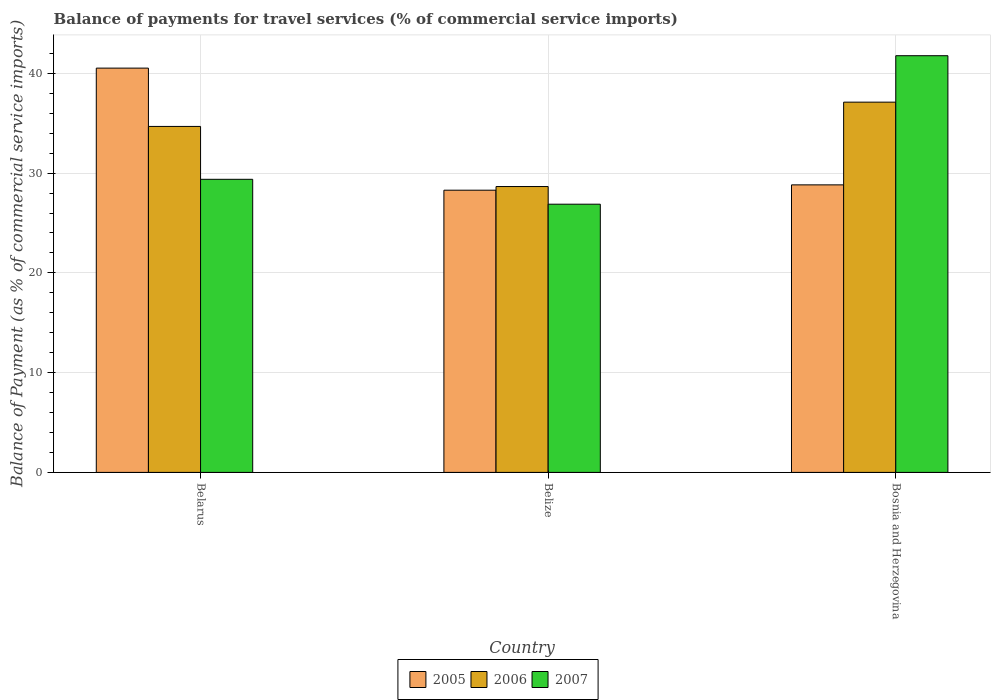How many different coloured bars are there?
Your answer should be compact. 3. Are the number of bars per tick equal to the number of legend labels?
Provide a short and direct response. Yes. Are the number of bars on each tick of the X-axis equal?
Your response must be concise. Yes. What is the label of the 3rd group of bars from the left?
Offer a terse response. Bosnia and Herzegovina. In how many cases, is the number of bars for a given country not equal to the number of legend labels?
Your answer should be very brief. 0. What is the balance of payments for travel services in 2005 in Bosnia and Herzegovina?
Your response must be concise. 28.82. Across all countries, what is the maximum balance of payments for travel services in 2007?
Make the answer very short. 41.77. Across all countries, what is the minimum balance of payments for travel services in 2007?
Keep it short and to the point. 26.89. In which country was the balance of payments for travel services in 2005 maximum?
Offer a very short reply. Belarus. In which country was the balance of payments for travel services in 2007 minimum?
Your answer should be very brief. Belize. What is the total balance of payments for travel services in 2005 in the graph?
Keep it short and to the point. 97.64. What is the difference between the balance of payments for travel services in 2006 in Belize and that in Bosnia and Herzegovina?
Your answer should be very brief. -8.46. What is the difference between the balance of payments for travel services in 2005 in Bosnia and Herzegovina and the balance of payments for travel services in 2007 in Belarus?
Offer a terse response. -0.56. What is the average balance of payments for travel services in 2007 per country?
Your answer should be compact. 32.68. What is the difference between the balance of payments for travel services of/in 2006 and balance of payments for travel services of/in 2005 in Belarus?
Your answer should be compact. -5.85. In how many countries, is the balance of payments for travel services in 2005 greater than 26 %?
Keep it short and to the point. 3. What is the ratio of the balance of payments for travel services in 2006 in Belize to that in Bosnia and Herzegovina?
Ensure brevity in your answer.  0.77. What is the difference between the highest and the second highest balance of payments for travel services in 2005?
Ensure brevity in your answer.  11.7. What is the difference between the highest and the lowest balance of payments for travel services in 2007?
Your answer should be very brief. 14.88. Is the sum of the balance of payments for travel services in 2006 in Belarus and Bosnia and Herzegovina greater than the maximum balance of payments for travel services in 2007 across all countries?
Your answer should be compact. Yes. What does the 3rd bar from the right in Bosnia and Herzegovina represents?
Keep it short and to the point. 2005. Is it the case that in every country, the sum of the balance of payments for travel services in 2006 and balance of payments for travel services in 2007 is greater than the balance of payments for travel services in 2005?
Your answer should be compact. Yes. How many bars are there?
Your answer should be compact. 9. Are all the bars in the graph horizontal?
Your response must be concise. No. What is the difference between two consecutive major ticks on the Y-axis?
Provide a succinct answer. 10. Are the values on the major ticks of Y-axis written in scientific E-notation?
Your answer should be very brief. No. Where does the legend appear in the graph?
Offer a terse response. Bottom center. How many legend labels are there?
Offer a terse response. 3. How are the legend labels stacked?
Your answer should be very brief. Horizontal. What is the title of the graph?
Provide a succinct answer. Balance of payments for travel services (% of commercial service imports). What is the label or title of the Y-axis?
Make the answer very short. Balance of Payment (as % of commercial service imports). What is the Balance of Payment (as % of commercial service imports) in 2005 in Belarus?
Keep it short and to the point. 40.53. What is the Balance of Payment (as % of commercial service imports) in 2006 in Belarus?
Your response must be concise. 34.68. What is the Balance of Payment (as % of commercial service imports) of 2007 in Belarus?
Your response must be concise. 29.38. What is the Balance of Payment (as % of commercial service imports) of 2005 in Belize?
Offer a very short reply. 28.29. What is the Balance of Payment (as % of commercial service imports) in 2006 in Belize?
Provide a short and direct response. 28.66. What is the Balance of Payment (as % of commercial service imports) of 2007 in Belize?
Give a very brief answer. 26.89. What is the Balance of Payment (as % of commercial service imports) of 2005 in Bosnia and Herzegovina?
Keep it short and to the point. 28.82. What is the Balance of Payment (as % of commercial service imports) in 2006 in Bosnia and Herzegovina?
Offer a terse response. 37.12. What is the Balance of Payment (as % of commercial service imports) in 2007 in Bosnia and Herzegovina?
Provide a short and direct response. 41.77. Across all countries, what is the maximum Balance of Payment (as % of commercial service imports) in 2005?
Provide a succinct answer. 40.53. Across all countries, what is the maximum Balance of Payment (as % of commercial service imports) in 2006?
Give a very brief answer. 37.12. Across all countries, what is the maximum Balance of Payment (as % of commercial service imports) in 2007?
Make the answer very short. 41.77. Across all countries, what is the minimum Balance of Payment (as % of commercial service imports) of 2005?
Your answer should be very brief. 28.29. Across all countries, what is the minimum Balance of Payment (as % of commercial service imports) in 2006?
Your answer should be very brief. 28.66. Across all countries, what is the minimum Balance of Payment (as % of commercial service imports) in 2007?
Offer a very short reply. 26.89. What is the total Balance of Payment (as % of commercial service imports) in 2005 in the graph?
Ensure brevity in your answer.  97.64. What is the total Balance of Payment (as % of commercial service imports) in 2006 in the graph?
Keep it short and to the point. 100.45. What is the total Balance of Payment (as % of commercial service imports) in 2007 in the graph?
Offer a terse response. 98.04. What is the difference between the Balance of Payment (as % of commercial service imports) in 2005 in Belarus and that in Belize?
Your response must be concise. 12.24. What is the difference between the Balance of Payment (as % of commercial service imports) of 2006 in Belarus and that in Belize?
Your response must be concise. 6.03. What is the difference between the Balance of Payment (as % of commercial service imports) in 2007 in Belarus and that in Belize?
Ensure brevity in your answer.  2.49. What is the difference between the Balance of Payment (as % of commercial service imports) in 2005 in Belarus and that in Bosnia and Herzegovina?
Your answer should be compact. 11.7. What is the difference between the Balance of Payment (as % of commercial service imports) in 2006 in Belarus and that in Bosnia and Herzegovina?
Your answer should be compact. -2.43. What is the difference between the Balance of Payment (as % of commercial service imports) of 2007 in Belarus and that in Bosnia and Herzegovina?
Offer a very short reply. -12.39. What is the difference between the Balance of Payment (as % of commercial service imports) in 2005 in Belize and that in Bosnia and Herzegovina?
Your answer should be very brief. -0.53. What is the difference between the Balance of Payment (as % of commercial service imports) in 2006 in Belize and that in Bosnia and Herzegovina?
Give a very brief answer. -8.46. What is the difference between the Balance of Payment (as % of commercial service imports) of 2007 in Belize and that in Bosnia and Herzegovina?
Give a very brief answer. -14.88. What is the difference between the Balance of Payment (as % of commercial service imports) of 2005 in Belarus and the Balance of Payment (as % of commercial service imports) of 2006 in Belize?
Offer a terse response. 11.87. What is the difference between the Balance of Payment (as % of commercial service imports) in 2005 in Belarus and the Balance of Payment (as % of commercial service imports) in 2007 in Belize?
Provide a succinct answer. 13.64. What is the difference between the Balance of Payment (as % of commercial service imports) of 2006 in Belarus and the Balance of Payment (as % of commercial service imports) of 2007 in Belize?
Your response must be concise. 7.8. What is the difference between the Balance of Payment (as % of commercial service imports) of 2005 in Belarus and the Balance of Payment (as % of commercial service imports) of 2006 in Bosnia and Herzegovina?
Provide a short and direct response. 3.41. What is the difference between the Balance of Payment (as % of commercial service imports) of 2005 in Belarus and the Balance of Payment (as % of commercial service imports) of 2007 in Bosnia and Herzegovina?
Offer a terse response. -1.24. What is the difference between the Balance of Payment (as % of commercial service imports) in 2006 in Belarus and the Balance of Payment (as % of commercial service imports) in 2007 in Bosnia and Herzegovina?
Provide a succinct answer. -7.09. What is the difference between the Balance of Payment (as % of commercial service imports) in 2005 in Belize and the Balance of Payment (as % of commercial service imports) in 2006 in Bosnia and Herzegovina?
Ensure brevity in your answer.  -8.83. What is the difference between the Balance of Payment (as % of commercial service imports) of 2005 in Belize and the Balance of Payment (as % of commercial service imports) of 2007 in Bosnia and Herzegovina?
Your response must be concise. -13.48. What is the difference between the Balance of Payment (as % of commercial service imports) of 2006 in Belize and the Balance of Payment (as % of commercial service imports) of 2007 in Bosnia and Herzegovina?
Give a very brief answer. -13.12. What is the average Balance of Payment (as % of commercial service imports) of 2005 per country?
Provide a short and direct response. 32.55. What is the average Balance of Payment (as % of commercial service imports) of 2006 per country?
Provide a succinct answer. 33.48. What is the average Balance of Payment (as % of commercial service imports) in 2007 per country?
Your answer should be compact. 32.68. What is the difference between the Balance of Payment (as % of commercial service imports) of 2005 and Balance of Payment (as % of commercial service imports) of 2006 in Belarus?
Your response must be concise. 5.85. What is the difference between the Balance of Payment (as % of commercial service imports) in 2005 and Balance of Payment (as % of commercial service imports) in 2007 in Belarus?
Ensure brevity in your answer.  11.15. What is the difference between the Balance of Payment (as % of commercial service imports) in 2006 and Balance of Payment (as % of commercial service imports) in 2007 in Belarus?
Provide a short and direct response. 5.3. What is the difference between the Balance of Payment (as % of commercial service imports) in 2005 and Balance of Payment (as % of commercial service imports) in 2006 in Belize?
Provide a succinct answer. -0.37. What is the difference between the Balance of Payment (as % of commercial service imports) in 2005 and Balance of Payment (as % of commercial service imports) in 2007 in Belize?
Offer a terse response. 1.4. What is the difference between the Balance of Payment (as % of commercial service imports) of 2006 and Balance of Payment (as % of commercial service imports) of 2007 in Belize?
Offer a terse response. 1.77. What is the difference between the Balance of Payment (as % of commercial service imports) in 2005 and Balance of Payment (as % of commercial service imports) in 2006 in Bosnia and Herzegovina?
Provide a succinct answer. -8.29. What is the difference between the Balance of Payment (as % of commercial service imports) in 2005 and Balance of Payment (as % of commercial service imports) in 2007 in Bosnia and Herzegovina?
Provide a succinct answer. -12.95. What is the difference between the Balance of Payment (as % of commercial service imports) in 2006 and Balance of Payment (as % of commercial service imports) in 2007 in Bosnia and Herzegovina?
Make the answer very short. -4.66. What is the ratio of the Balance of Payment (as % of commercial service imports) of 2005 in Belarus to that in Belize?
Offer a terse response. 1.43. What is the ratio of the Balance of Payment (as % of commercial service imports) in 2006 in Belarus to that in Belize?
Offer a terse response. 1.21. What is the ratio of the Balance of Payment (as % of commercial service imports) in 2007 in Belarus to that in Belize?
Your answer should be compact. 1.09. What is the ratio of the Balance of Payment (as % of commercial service imports) in 2005 in Belarus to that in Bosnia and Herzegovina?
Your answer should be compact. 1.41. What is the ratio of the Balance of Payment (as % of commercial service imports) of 2006 in Belarus to that in Bosnia and Herzegovina?
Keep it short and to the point. 0.93. What is the ratio of the Balance of Payment (as % of commercial service imports) in 2007 in Belarus to that in Bosnia and Herzegovina?
Make the answer very short. 0.7. What is the ratio of the Balance of Payment (as % of commercial service imports) in 2005 in Belize to that in Bosnia and Herzegovina?
Keep it short and to the point. 0.98. What is the ratio of the Balance of Payment (as % of commercial service imports) of 2006 in Belize to that in Bosnia and Herzegovina?
Provide a succinct answer. 0.77. What is the ratio of the Balance of Payment (as % of commercial service imports) of 2007 in Belize to that in Bosnia and Herzegovina?
Provide a short and direct response. 0.64. What is the difference between the highest and the second highest Balance of Payment (as % of commercial service imports) of 2005?
Your answer should be very brief. 11.7. What is the difference between the highest and the second highest Balance of Payment (as % of commercial service imports) in 2006?
Give a very brief answer. 2.43. What is the difference between the highest and the second highest Balance of Payment (as % of commercial service imports) of 2007?
Provide a short and direct response. 12.39. What is the difference between the highest and the lowest Balance of Payment (as % of commercial service imports) of 2005?
Your answer should be very brief. 12.24. What is the difference between the highest and the lowest Balance of Payment (as % of commercial service imports) in 2006?
Your response must be concise. 8.46. What is the difference between the highest and the lowest Balance of Payment (as % of commercial service imports) in 2007?
Provide a short and direct response. 14.88. 